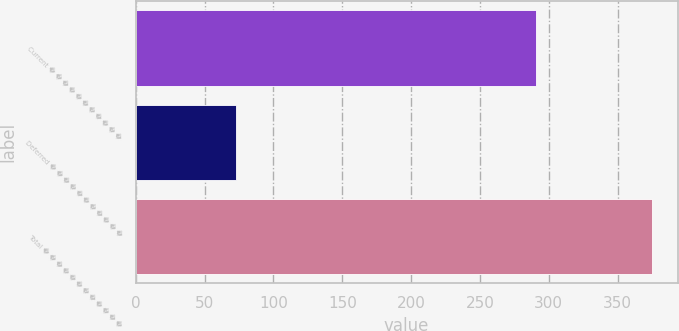Convert chart. <chart><loc_0><loc_0><loc_500><loc_500><bar_chart><fcel>Current � � � � � � � � � � �<fcel>Deferred � � � � � � � � � � �<fcel>Total � � � � � � � � � � � �<nl><fcel>291<fcel>73<fcel>374.8<nl></chart> 